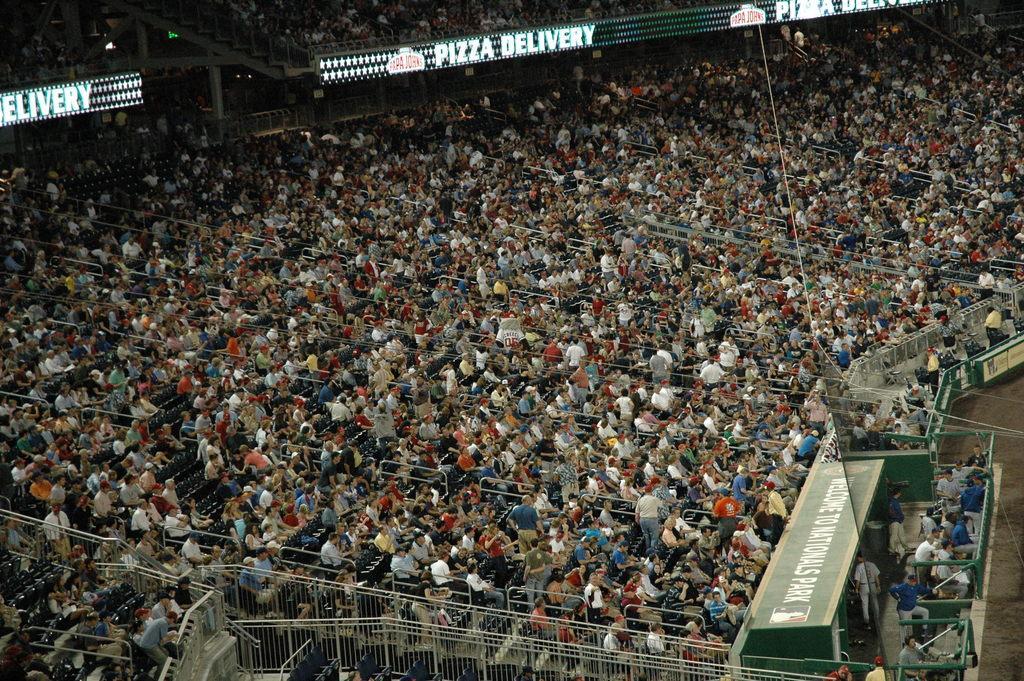Please provide a concise description of this image. It seems to be a stadium. Here I can see a crowd of people sitting facing towards the right side. On the right side, I can see the ground and few boards. 